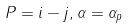<formula> <loc_0><loc_0><loc_500><loc_500>P = i - j , \alpha = \alpha _ { p }</formula> 